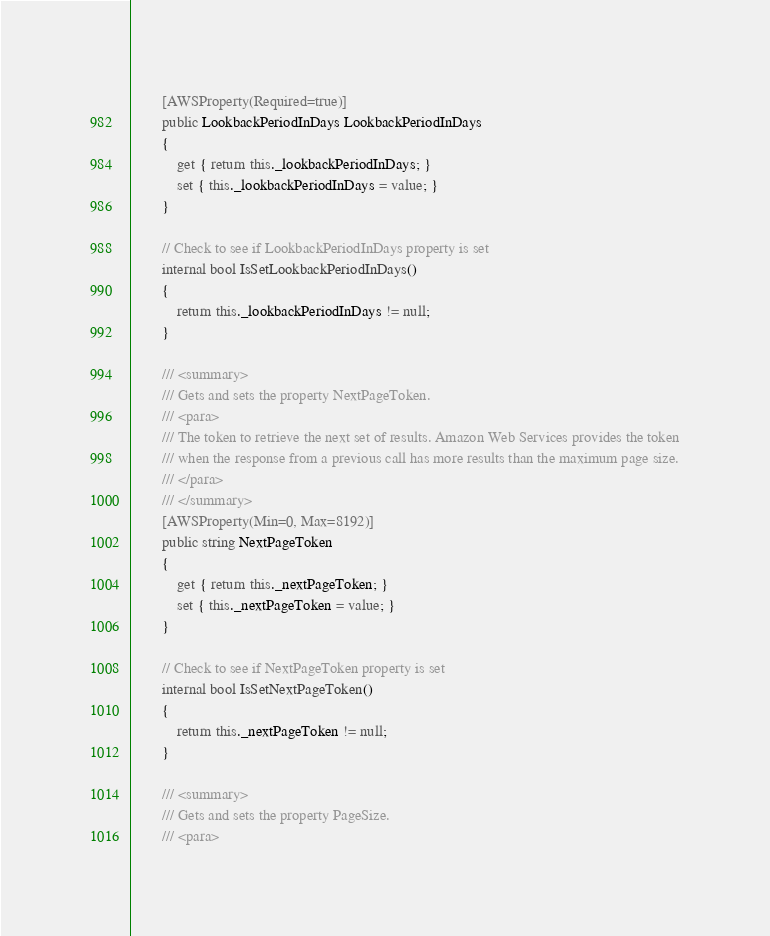<code> <loc_0><loc_0><loc_500><loc_500><_C#_>        [AWSProperty(Required=true)]
        public LookbackPeriodInDays LookbackPeriodInDays
        {
            get { return this._lookbackPeriodInDays; }
            set { this._lookbackPeriodInDays = value; }
        }

        // Check to see if LookbackPeriodInDays property is set
        internal bool IsSetLookbackPeriodInDays()
        {
            return this._lookbackPeriodInDays != null;
        }

        /// <summary>
        /// Gets and sets the property NextPageToken. 
        /// <para>
        /// The token to retrieve the next set of results. Amazon Web Services provides the token
        /// when the response from a previous call has more results than the maximum page size.
        /// </para>
        /// </summary>
        [AWSProperty(Min=0, Max=8192)]
        public string NextPageToken
        {
            get { return this._nextPageToken; }
            set { this._nextPageToken = value; }
        }

        // Check to see if NextPageToken property is set
        internal bool IsSetNextPageToken()
        {
            return this._nextPageToken != null;
        }

        /// <summary>
        /// Gets and sets the property PageSize. 
        /// <para></code> 